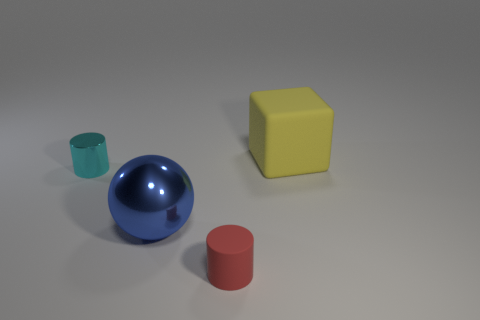Is there anything else that is the same color as the block?
Your answer should be compact. No. There is a rubber thing that is in front of the small object to the left of the red thing; how many spheres are in front of it?
Your answer should be compact. 0. How many yellow things are either metal spheres or big objects?
Ensure brevity in your answer.  1. Is the size of the red object the same as the yellow object on the right side of the metal cylinder?
Give a very brief answer. No. There is another object that is the same shape as the tiny cyan object; what is it made of?
Make the answer very short. Rubber. What number of other objects are the same size as the red rubber cylinder?
Offer a very short reply. 1. There is a tiny thing on the right side of the cylinder left of the tiny object in front of the sphere; what shape is it?
Offer a terse response. Cylinder. There is a thing that is both right of the blue shiny object and in front of the rubber cube; what is its shape?
Make the answer very short. Cylinder. How many things are either tiny cyan rubber cylinders or things to the right of the large ball?
Provide a succinct answer. 2. Does the cyan object have the same material as the tiny red cylinder?
Offer a terse response. No. 